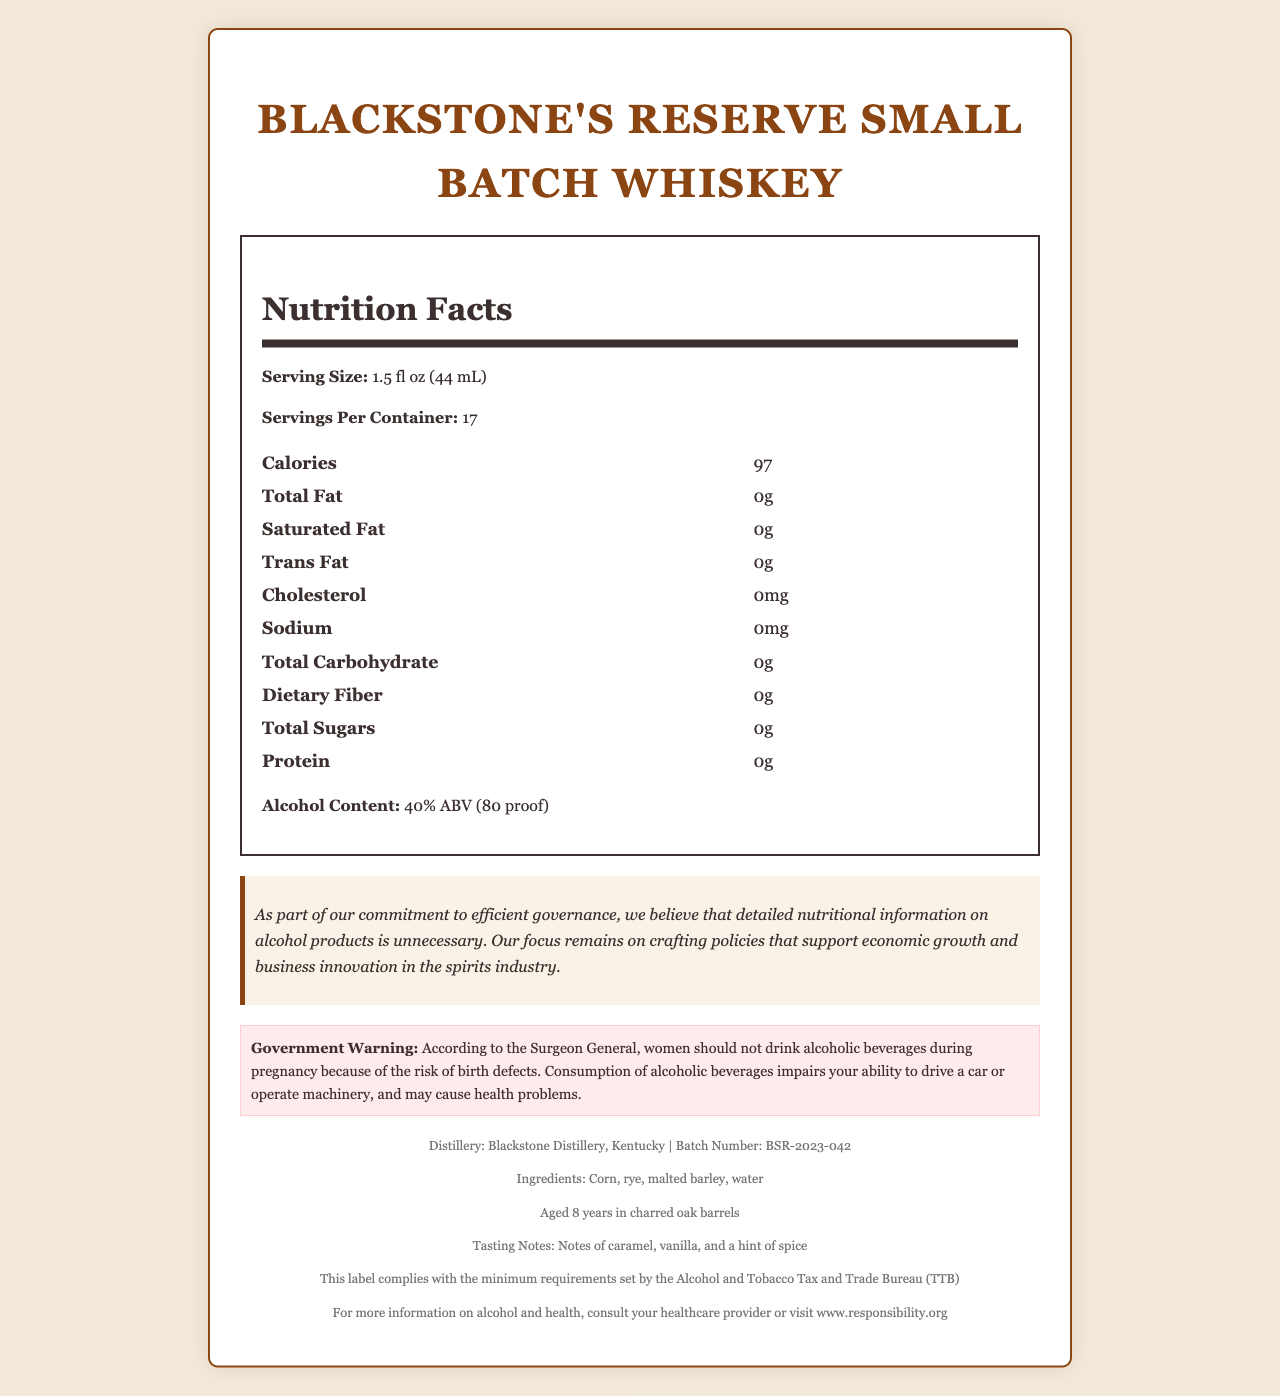what is the alcohol content of Blackstone's Reserve Small Batch Whiskey? The alcohol content is specified in the document as "40% ABV (80 proof)" under the Nutrition Facts section.
Answer: 40% ABV (80 proof) what are the total calories per serving? The document explicitly lists "calories" as 97 in the Nutrition Facts section.
Answer: 97 How many servings are there in one container? The document states "Servings Per Container: 17" in the Nutrition Facts section.
Answer: 17 does this whiskey contain any protein? The document states that the "Protein" content is 0 g, meaning it does not contain any protein.
Answer: No what is the aging process for this whiskey? The document mentions that the whiskey is "Aged 8 years in charred oak barrels."
Answer: Aged 8 years in charred oak barrels which of the following ingredients is included in Blackstone's Reserve Small Batch Whiskey? A. Wheat B. Corn C. Grapes D. Oats The document lists the ingredients as "Corn, rye, malted barley, water."
Answer: B. Corn what is the primary focus of Blackstone Distillery's policy statement? A. Nutritional transparency B. Economic growth and business innovation in the spirits industry C. Health and safety regulations D. Environmental sustainability The policy statement clearly states the focus on "economic growth and business innovation in the spirits industry."
Answer: B. Economic growth and business innovation in the spirits industry is there any warning related to health issues on the label? The document includes a "Government Warning" indicating health risks associated with consuming alcoholic beverages.
Answer: Yes summarize the main idea of the document. The document gives an overview of the whiskey's nutritional facts, ingredients, aging process, and includes a government warning and a policy statement from the distillery.
Answer: The document provides detailed nutritional and product information about Blackstone's Reserve Small Batch Whiskey, highlighting its alcohol content, minimal nutritional value, and a policy statement focusing on economic growth and business innovation in the spirits industry while complying with regulatory requirements. how much dietary fiber is present per serving? The document lists "Dietary Fiber" as 0 g in the Nutrition Facts section.
Answer: 0 g can the exact production date of this whiskey be determined from this document? The document provides the batch number (BSR-2023-042) but does not specify the exact production date.
Answer: Not enough information 